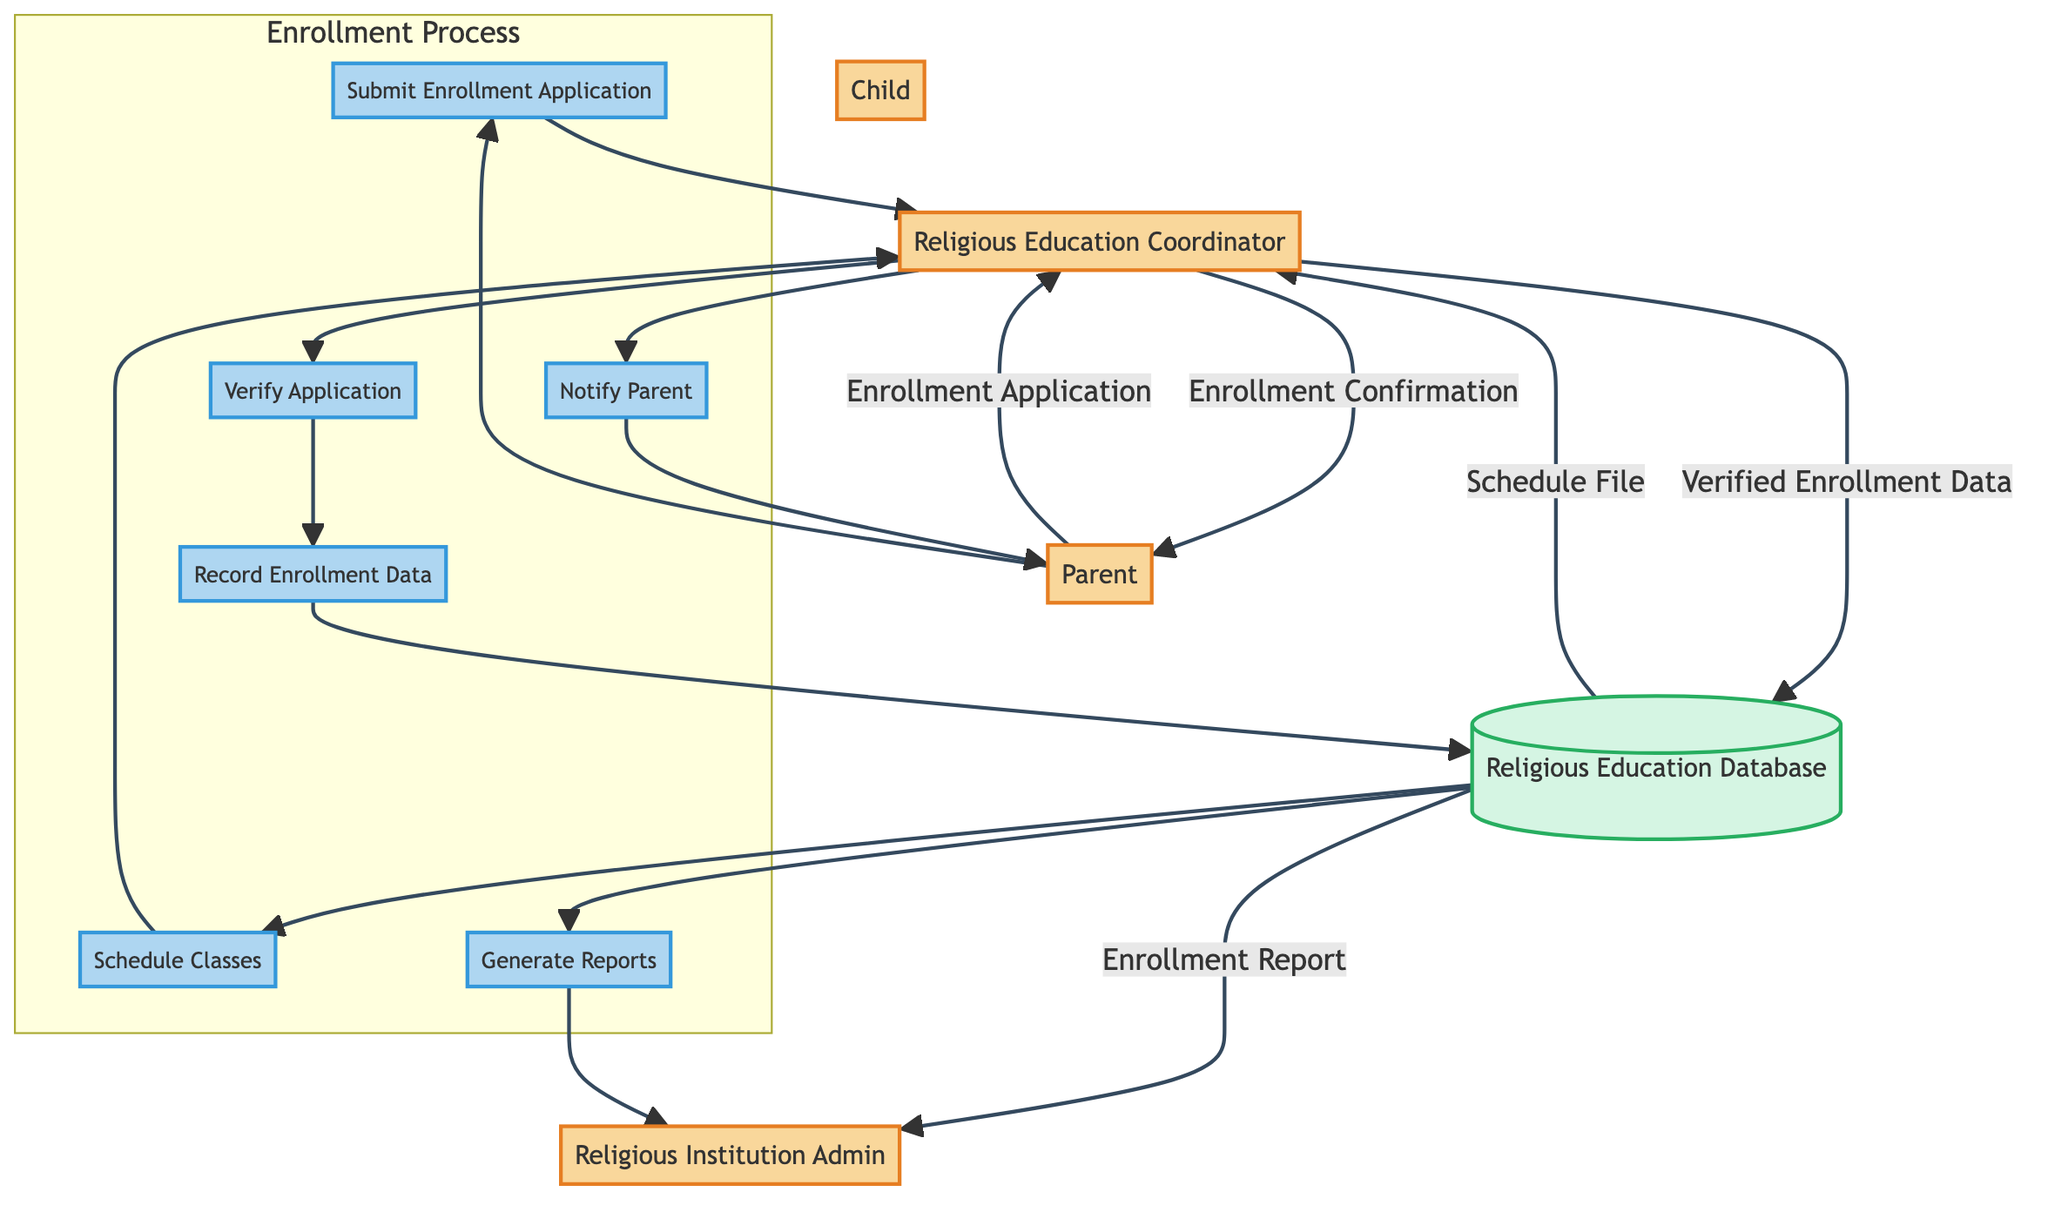What is the first entity involved in the enrollment process? The first entity in the diagram is the Parent, as they initiate the process by submitting an enrollment application.
Answer: Parent How many processes are depicted in the diagram? The diagram contains six processes related to the enrollment process as illustrated within the Enrollment Process subgraph.
Answer: Six What information does the Religious Education Coordinator send to the Parent? The Coordinator sends an Enrollment Confirmation, which includes confirmation and scheduling information about the classes.
Answer: Enrollment Confirmation What does the Religious Education Database provide to the Religious Education Coordinator? The Database provides a Schedule File that contains scheduling information based on the recorded enrollment data.
Answer: Schedule File What is the last action taken in the enrollment process? The last action is the generation of reports by the Religious Institution Admin, which reviews the information from the Religious Education Database.
Answer: Generate Reports Which entity submits the enrollment application? The enrollment application is submitted by the Parent, who is motivated by their hopes for their child's religious education.
Answer: Parent What data flow occurs after the Coordinator verifies the application? After verification, the flow of Verified Enrollment Data occurs, which is recorded in the Religious Education Database.
Answer: Verified Enrollment Data How many entities are there in the diagram? The diagram contains five entities that play distinct roles in the enrollment process for the religious education class.
Answer: Five What triggers the Scheduling of Classes? The Scheduling of Classes is triggered by the completion of recording enrollment data in the Religious Education Database.
Answer: Enrollment Data 